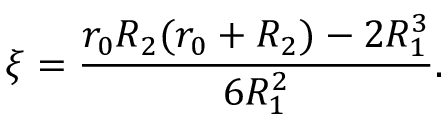<formula> <loc_0><loc_0><loc_500><loc_500>\xi = \frac { r _ { 0 } R _ { 2 } ( r _ { 0 } + R _ { 2 } ) - 2 R _ { 1 } ^ { 3 } } { 6 R _ { 1 } ^ { 2 } } .</formula> 